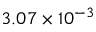<formula> <loc_0><loc_0><loc_500><loc_500>3 . 0 7 \times 1 0 ^ { - 3 }</formula> 